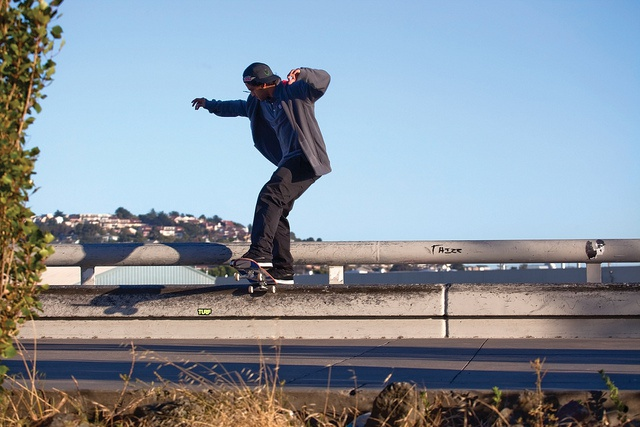Describe the objects in this image and their specific colors. I can see people in brown, black, gray, and navy tones and skateboard in brown, gray, and black tones in this image. 